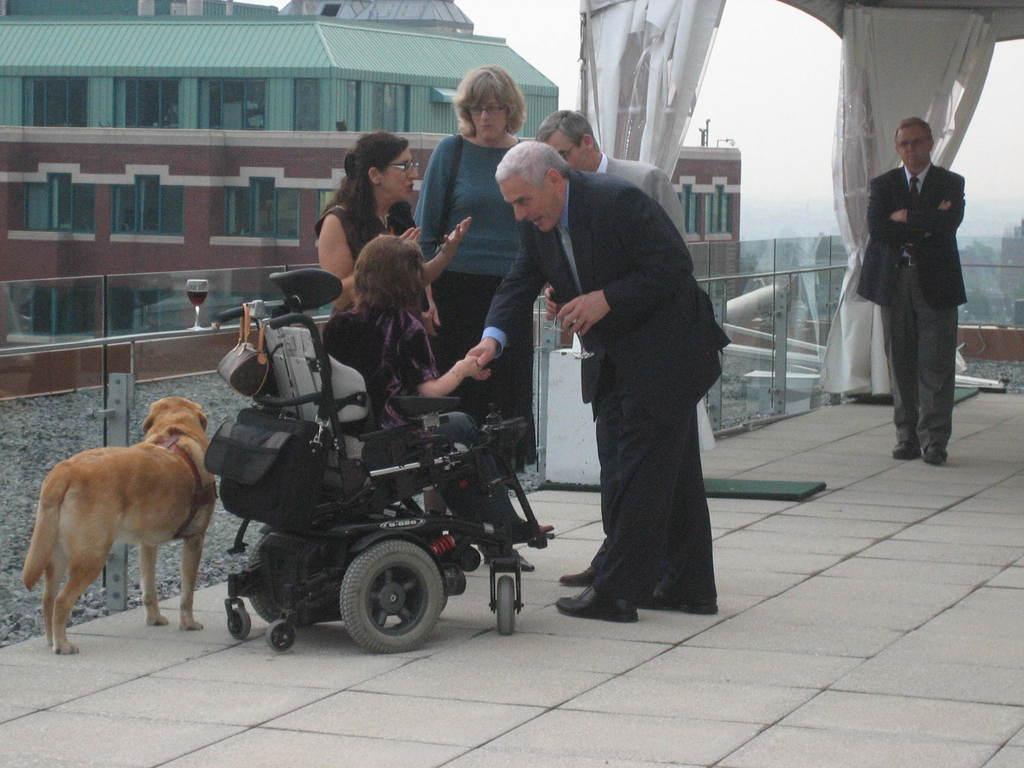Describe this image in one or two sentences. In the middle of the picture there are group of people, dog, glass and railing. Towards right there are curtains. On the left there are buildings. In the background towards right there are trees. At the top there is sky. At the bottom it is floor. In the center towards left we can see gravel stones. 